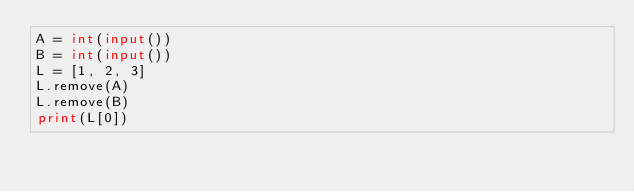<code> <loc_0><loc_0><loc_500><loc_500><_Python_>A = int(input())
B = int(input())
L = [1, 2, 3]
L.remove(A)
L.remove(B)
print(L[0])</code> 